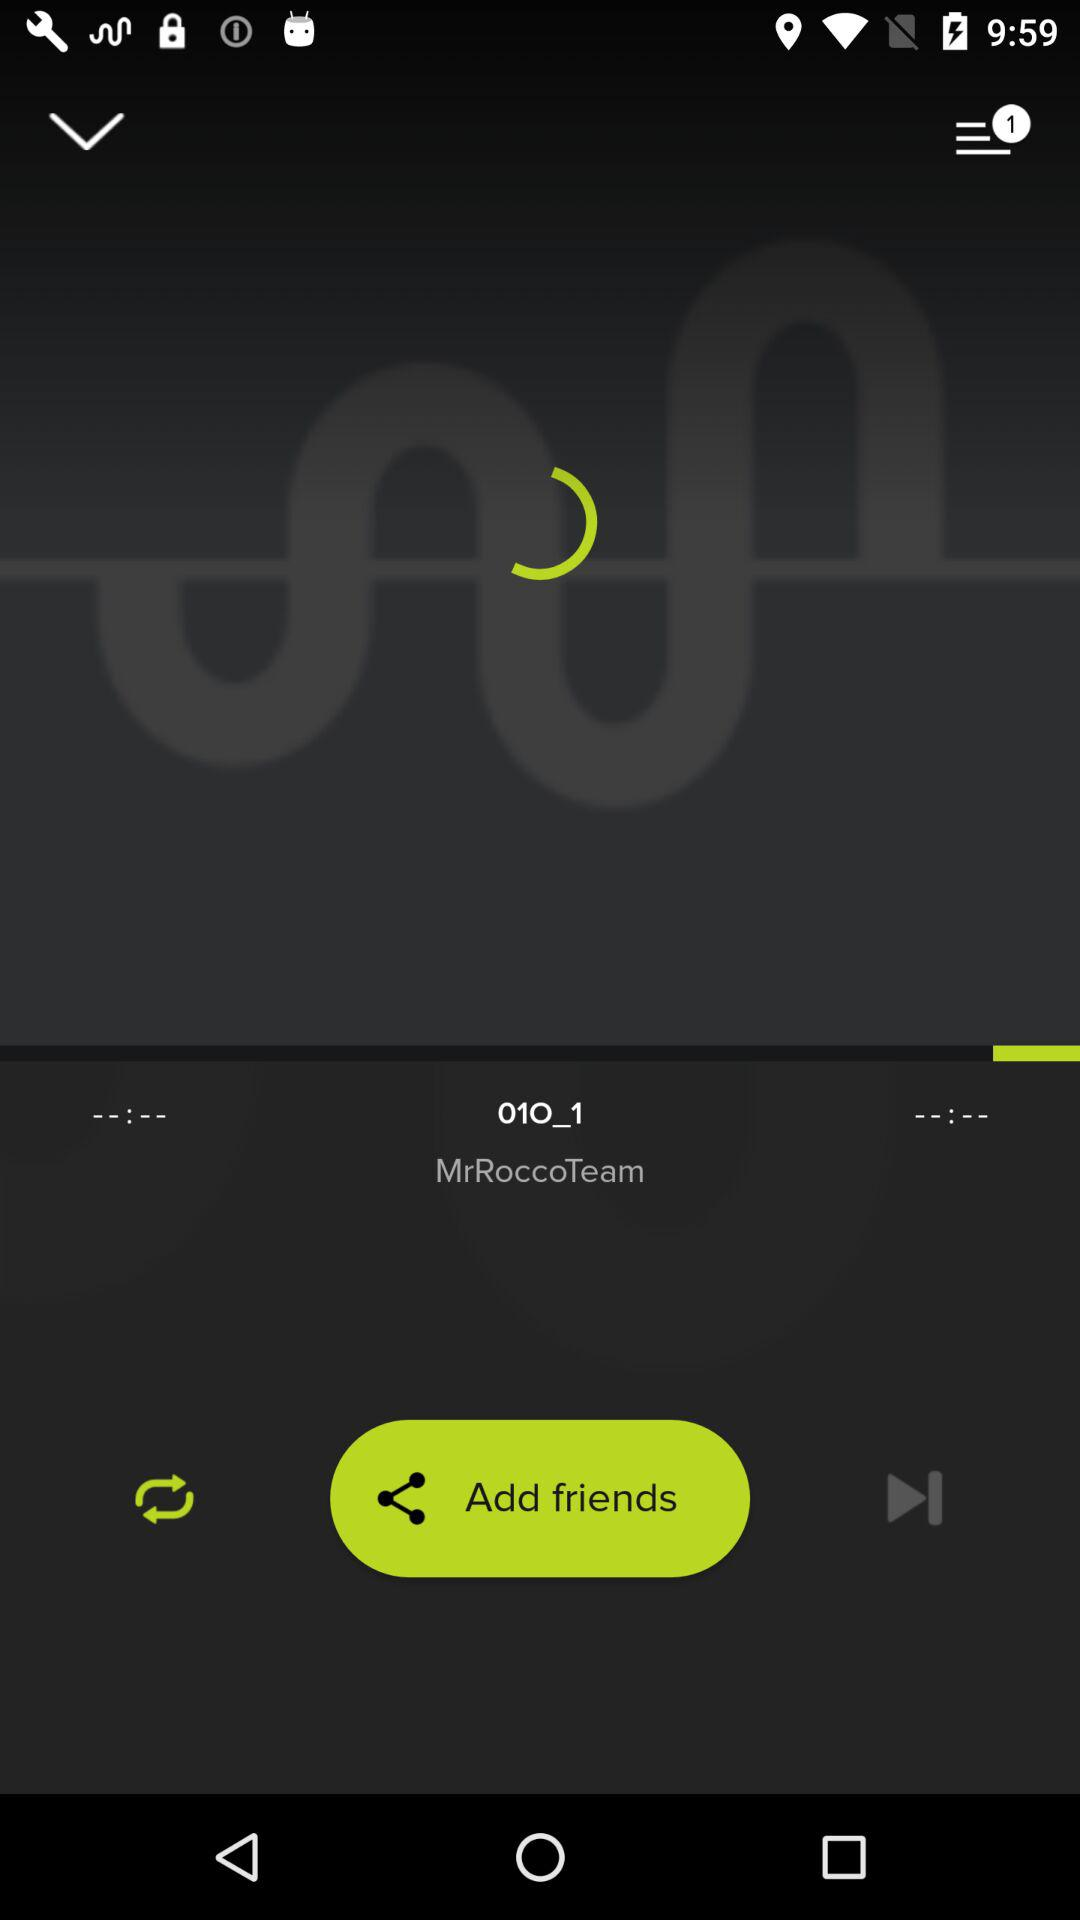How many black backgrounds with white lines are there?
Answer the question using a single word or phrase. 2 